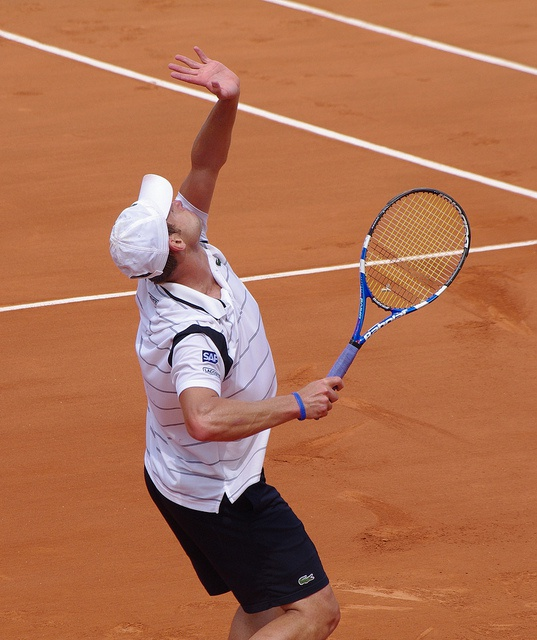Describe the objects in this image and their specific colors. I can see people in salmon, black, lavender, brown, and darkgray tones and tennis racket in salmon, red, and tan tones in this image. 